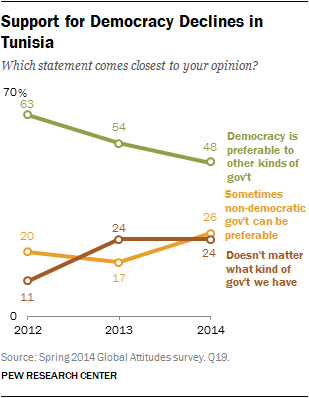Point out several critical features in this image. According to data, the percentage of people who prefer democracy reached its peak in 2012. The percentage of favoring democracy in 2014 was not larger than the sum of the other two attitudes. 